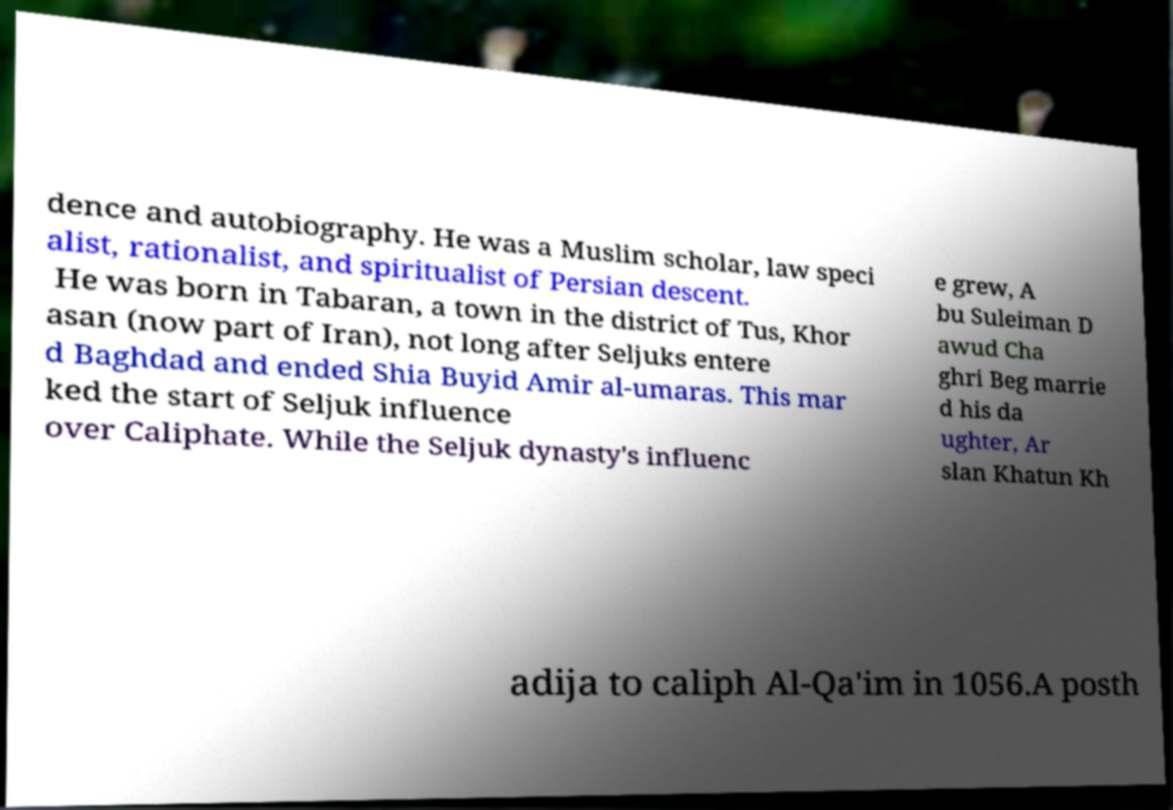Please identify and transcribe the text found in this image. dence and autobiography. He was a Muslim scholar, law speci alist, rationalist, and spiritualist of Persian descent. He was born in Tabaran, a town in the district of Tus, Khor asan (now part of Iran), not long after Seljuks entere d Baghdad and ended Shia Buyid Amir al-umaras. This mar ked the start of Seljuk influence over Caliphate. While the Seljuk dynasty's influenc e grew, A bu Suleiman D awud Cha ghri Beg marrie d his da ughter, Ar slan Khatun Kh adija to caliph Al-Qa'im in 1056.A posth 